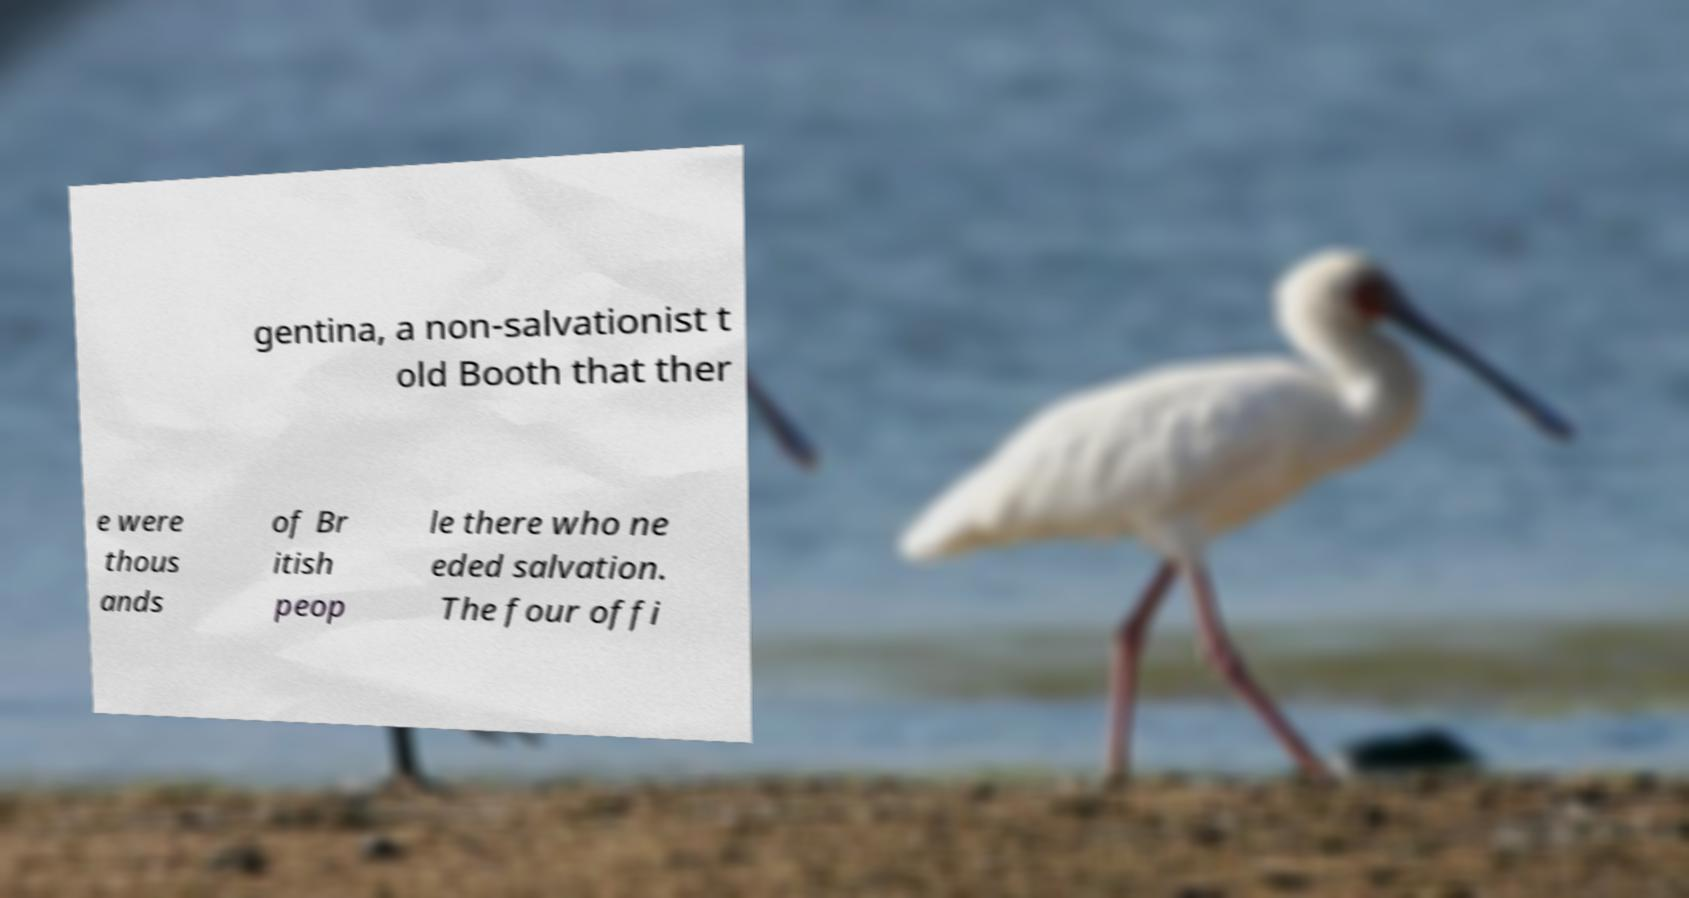Can you read and provide the text displayed in the image?This photo seems to have some interesting text. Can you extract and type it out for me? gentina, a non-salvationist t old Booth that ther e were thous ands of Br itish peop le there who ne eded salvation. The four offi 